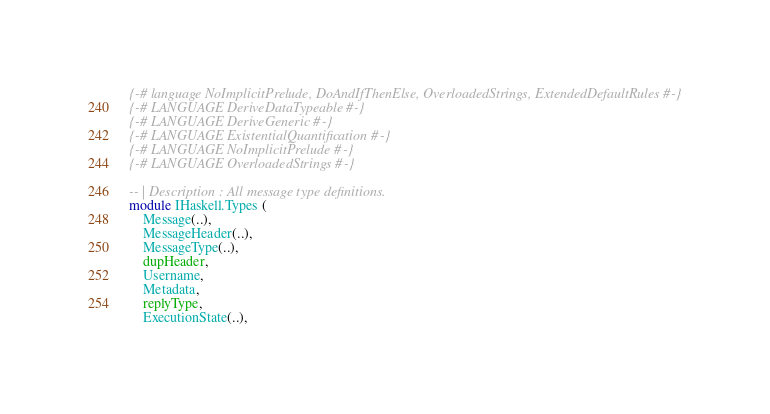<code> <loc_0><loc_0><loc_500><loc_500><_Haskell_>{-# language NoImplicitPrelude, DoAndIfThenElse, OverloadedStrings, ExtendedDefaultRules #-}
{-# LANGUAGE DeriveDataTypeable #-}
{-# LANGUAGE DeriveGeneric #-}
{-# LANGUAGE ExistentialQuantification #-}
{-# LANGUAGE NoImplicitPrelude #-}
{-# LANGUAGE OverloadedStrings #-}

-- | Description : All message type definitions.
module IHaskell.Types (
    Message(..),
    MessageHeader(..),
    MessageType(..),
    dupHeader,
    Username,
    Metadata,
    replyType,
    ExecutionState(..),</code> 